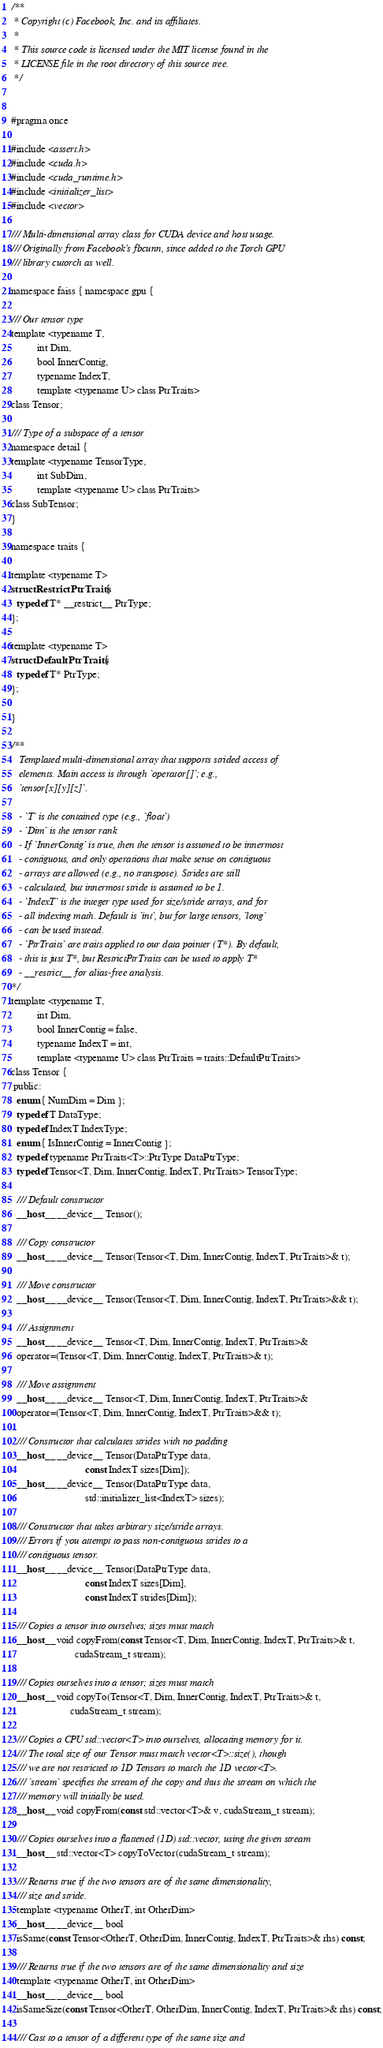<code> <loc_0><loc_0><loc_500><loc_500><_Cuda_>/**
 * Copyright (c) Facebook, Inc. and its affiliates.
 *
 * This source code is licensed under the MIT license found in the
 * LICENSE file in the root directory of this source tree.
 */


#pragma once

#include <assert.h>
#include <cuda.h>
#include <cuda_runtime.h>
#include <initializer_list>
#include <vector>

/// Multi-dimensional array class for CUDA device and host usage.
/// Originally from Facebook's fbcunn, since added to the Torch GPU
/// library cutorch as well.

namespace faiss { namespace gpu {

/// Our tensor type
template <typename T,
          int Dim,
          bool InnerContig,
          typename IndexT,
          template <typename U> class PtrTraits>
class Tensor;

/// Type of a subspace of a tensor
namespace detail {
template <typename TensorType,
          int SubDim,
          template <typename U> class PtrTraits>
class SubTensor;
}

namespace traits {

template <typename T>
struct RestrictPtrTraits {
  typedef T* __restrict__ PtrType;
};

template <typename T>
struct DefaultPtrTraits {
  typedef T* PtrType;
};

}

/**
   Templated multi-dimensional array that supports strided access of
   elements. Main access is through `operator[]`; e.g.,
   `tensor[x][y][z]`.

   - `T` is the contained type (e.g., `float`)
   - `Dim` is the tensor rank
   - If `InnerContig` is true, then the tensor is assumed to be innermost
   - contiguous, and only operations that make sense on contiguous
   - arrays are allowed (e.g., no transpose). Strides are still
   - calculated, but innermost stride is assumed to be 1.
   - `IndexT` is the integer type used for size/stride arrays, and for
   - all indexing math. Default is `int`, but for large tensors, `long`
   - can be used instead.
   - `PtrTraits` are traits applied to our data pointer (T*). By default,
   - this is just T*, but RestrictPtrTraits can be used to apply T*
   - __restrict__ for alias-free analysis.
*/
template <typename T,
          int Dim,
          bool InnerContig = false,
          typename IndexT = int,
          template <typename U> class PtrTraits = traits::DefaultPtrTraits>
class Tensor {
 public:
  enum { NumDim = Dim };
  typedef T DataType;
  typedef IndexT IndexType;
  enum { IsInnerContig = InnerContig };
  typedef typename PtrTraits<T>::PtrType DataPtrType;
  typedef Tensor<T, Dim, InnerContig, IndexT, PtrTraits> TensorType;

  /// Default constructor
  __host__ __device__ Tensor();

  /// Copy constructor
  __host__ __device__ Tensor(Tensor<T, Dim, InnerContig, IndexT, PtrTraits>& t);

  /// Move constructor
  __host__ __device__ Tensor(Tensor<T, Dim, InnerContig, IndexT, PtrTraits>&& t);

  /// Assignment
  __host__ __device__ Tensor<T, Dim, InnerContig, IndexT, PtrTraits>&
  operator=(Tensor<T, Dim, InnerContig, IndexT, PtrTraits>& t);

  /// Move assignment
  __host__ __device__ Tensor<T, Dim, InnerContig, IndexT, PtrTraits>&
  operator=(Tensor<T, Dim, InnerContig, IndexT, PtrTraits>&& t);

  /// Constructor that calculates strides with no padding
  __host__ __device__ Tensor(DataPtrType data,
                             const IndexT sizes[Dim]);
  __host__ __device__ Tensor(DataPtrType data,
                             std::initializer_list<IndexT> sizes);

  /// Constructor that takes arbitrary size/stride arrays.
  /// Errors if you attempt to pass non-contiguous strides to a
  /// contiguous tensor.
  __host__ __device__ Tensor(DataPtrType data,
                             const IndexT sizes[Dim],
                             const IndexT strides[Dim]);

  /// Copies a tensor into ourselves; sizes must match
  __host__ void copyFrom(const Tensor<T, Dim, InnerContig, IndexT, PtrTraits>& t,
                         cudaStream_t stream);

  /// Copies ourselves into a tensor; sizes must match
  __host__ void copyTo(Tensor<T, Dim, InnerContig, IndexT, PtrTraits>& t,
                       cudaStream_t stream);

  /// Copies a CPU std::vector<T> into ourselves, allocating memory for it.
  /// The total size of our Tensor must match vector<T>::size(), though
  /// we are not restricted to 1D Tensors to match the 1D vector<T>.
  /// `stream` specifies the stream of the copy and thus the stream on which the
  /// memory will initially be used.
  __host__ void copyFrom(const std::vector<T>& v, cudaStream_t stream);

  /// Copies ourselves into a flattened (1D) std::vector, using the given stream
  __host__ std::vector<T> copyToVector(cudaStream_t stream);

  /// Returns true if the two tensors are of the same dimensionality,
  /// size and stride.
  template <typename OtherT, int OtherDim>
  __host__ __device__ bool
  isSame(const Tensor<OtherT, OtherDim, InnerContig, IndexT, PtrTraits>& rhs) const;

  /// Returns true if the two tensors are of the same dimensionality and size
  template <typename OtherT, int OtherDim>
  __host__ __device__ bool
  isSameSize(const Tensor<OtherT, OtherDim, InnerContig, IndexT, PtrTraits>& rhs) const;

  /// Cast to a tensor of a different type of the same size and</code> 